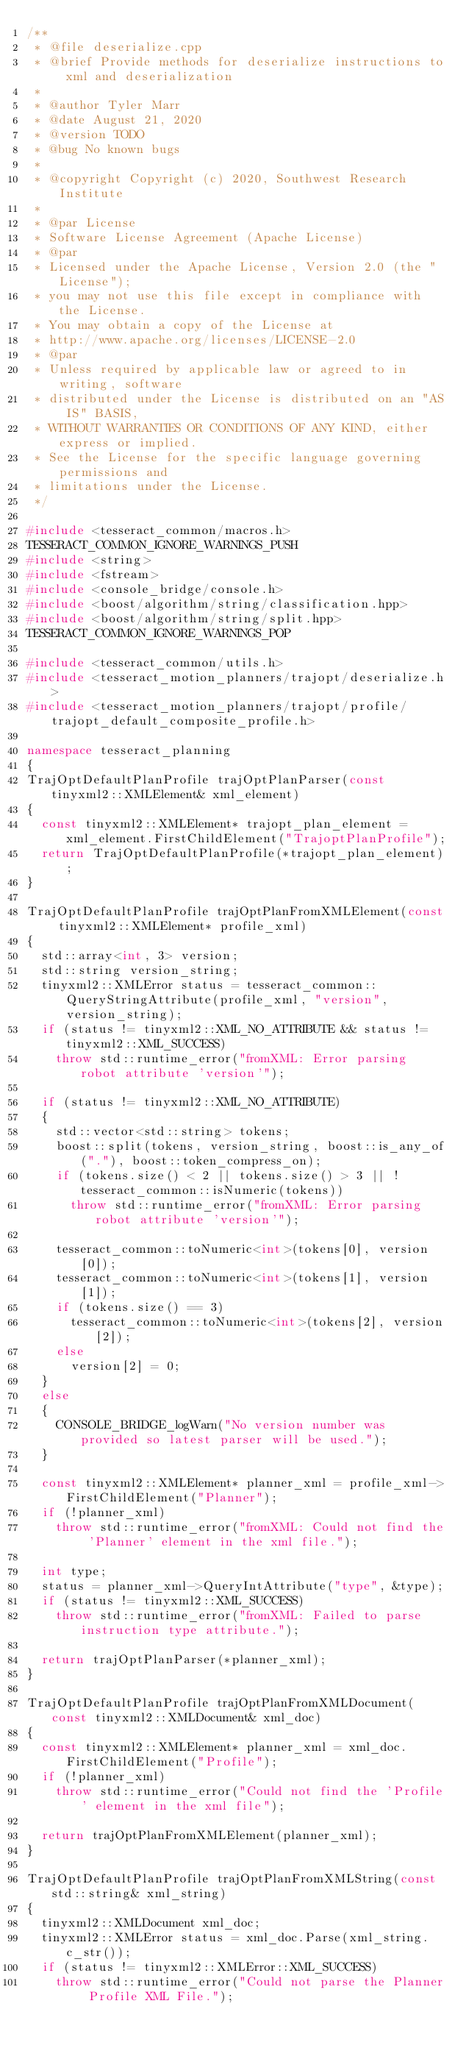<code> <loc_0><loc_0><loc_500><loc_500><_C++_>/**
 * @file deserialize.cpp
 * @brief Provide methods for deserialize instructions to xml and deserialization
 *
 * @author Tyler Marr
 * @date August 21, 2020
 * @version TODO
 * @bug No known bugs
 *
 * @copyright Copyright (c) 2020, Southwest Research Institute
 *
 * @par License
 * Software License Agreement (Apache License)
 * @par
 * Licensed under the Apache License, Version 2.0 (the "License");
 * you may not use this file except in compliance with the License.
 * You may obtain a copy of the License at
 * http://www.apache.org/licenses/LICENSE-2.0
 * @par
 * Unless required by applicable law or agreed to in writing, software
 * distributed under the License is distributed on an "AS IS" BASIS,
 * WITHOUT WARRANTIES OR CONDITIONS OF ANY KIND, either express or implied.
 * See the License for the specific language governing permissions and
 * limitations under the License.
 */

#include <tesseract_common/macros.h>
TESSERACT_COMMON_IGNORE_WARNINGS_PUSH
#include <string>
#include <fstream>
#include <console_bridge/console.h>
#include <boost/algorithm/string/classification.hpp>
#include <boost/algorithm/string/split.hpp>
TESSERACT_COMMON_IGNORE_WARNINGS_POP

#include <tesseract_common/utils.h>
#include <tesseract_motion_planners/trajopt/deserialize.h>
#include <tesseract_motion_planners/trajopt/profile/trajopt_default_composite_profile.h>

namespace tesseract_planning
{
TrajOptDefaultPlanProfile trajOptPlanParser(const tinyxml2::XMLElement& xml_element)
{
  const tinyxml2::XMLElement* trajopt_plan_element = xml_element.FirstChildElement("TrajoptPlanProfile");
  return TrajOptDefaultPlanProfile(*trajopt_plan_element);
}

TrajOptDefaultPlanProfile trajOptPlanFromXMLElement(const tinyxml2::XMLElement* profile_xml)
{
  std::array<int, 3> version;
  std::string version_string;
  tinyxml2::XMLError status = tesseract_common::QueryStringAttribute(profile_xml, "version", version_string);
  if (status != tinyxml2::XML_NO_ATTRIBUTE && status != tinyxml2::XML_SUCCESS)
    throw std::runtime_error("fromXML: Error parsing robot attribute 'version'");

  if (status != tinyxml2::XML_NO_ATTRIBUTE)
  {
    std::vector<std::string> tokens;
    boost::split(tokens, version_string, boost::is_any_of("."), boost::token_compress_on);
    if (tokens.size() < 2 || tokens.size() > 3 || !tesseract_common::isNumeric(tokens))
      throw std::runtime_error("fromXML: Error parsing robot attribute 'version'");

    tesseract_common::toNumeric<int>(tokens[0], version[0]);
    tesseract_common::toNumeric<int>(tokens[1], version[1]);
    if (tokens.size() == 3)
      tesseract_common::toNumeric<int>(tokens[2], version[2]);
    else
      version[2] = 0;
  }
  else
  {
    CONSOLE_BRIDGE_logWarn("No version number was provided so latest parser will be used.");
  }

  const tinyxml2::XMLElement* planner_xml = profile_xml->FirstChildElement("Planner");
  if (!planner_xml)
    throw std::runtime_error("fromXML: Could not find the 'Planner' element in the xml file.");

  int type;
  status = planner_xml->QueryIntAttribute("type", &type);
  if (status != tinyxml2::XML_SUCCESS)
    throw std::runtime_error("fromXML: Failed to parse instruction type attribute.");

  return trajOptPlanParser(*planner_xml);
}

TrajOptDefaultPlanProfile trajOptPlanFromXMLDocument(const tinyxml2::XMLDocument& xml_doc)
{
  const tinyxml2::XMLElement* planner_xml = xml_doc.FirstChildElement("Profile");
  if (!planner_xml)
    throw std::runtime_error("Could not find the 'Profile' element in the xml file");

  return trajOptPlanFromXMLElement(planner_xml);
}

TrajOptDefaultPlanProfile trajOptPlanFromXMLString(const std::string& xml_string)
{
  tinyxml2::XMLDocument xml_doc;
  tinyxml2::XMLError status = xml_doc.Parse(xml_string.c_str());
  if (status != tinyxml2::XMLError::XML_SUCCESS)
    throw std::runtime_error("Could not parse the Planner Profile XML File.");
</code> 